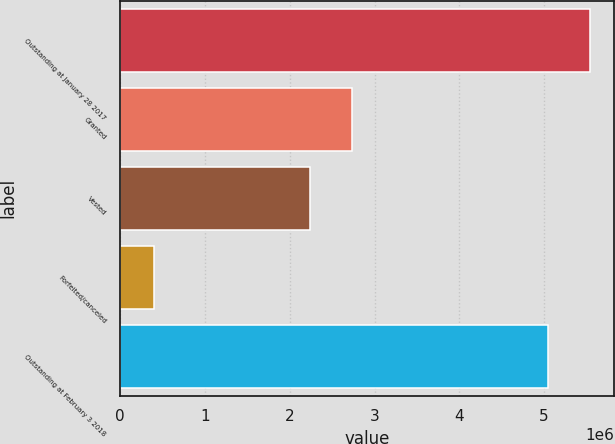Convert chart to OTSL. <chart><loc_0><loc_0><loc_500><loc_500><bar_chart><fcel>Outstanding at January 28 2017<fcel>Granted<fcel>Vested<fcel>Forfeited/canceled<fcel>Outstanding at February 3 2018<nl><fcel>5.5466e+06<fcel>2.7386e+06<fcel>2.242e+06<fcel>399000<fcel>5.05e+06<nl></chart> 